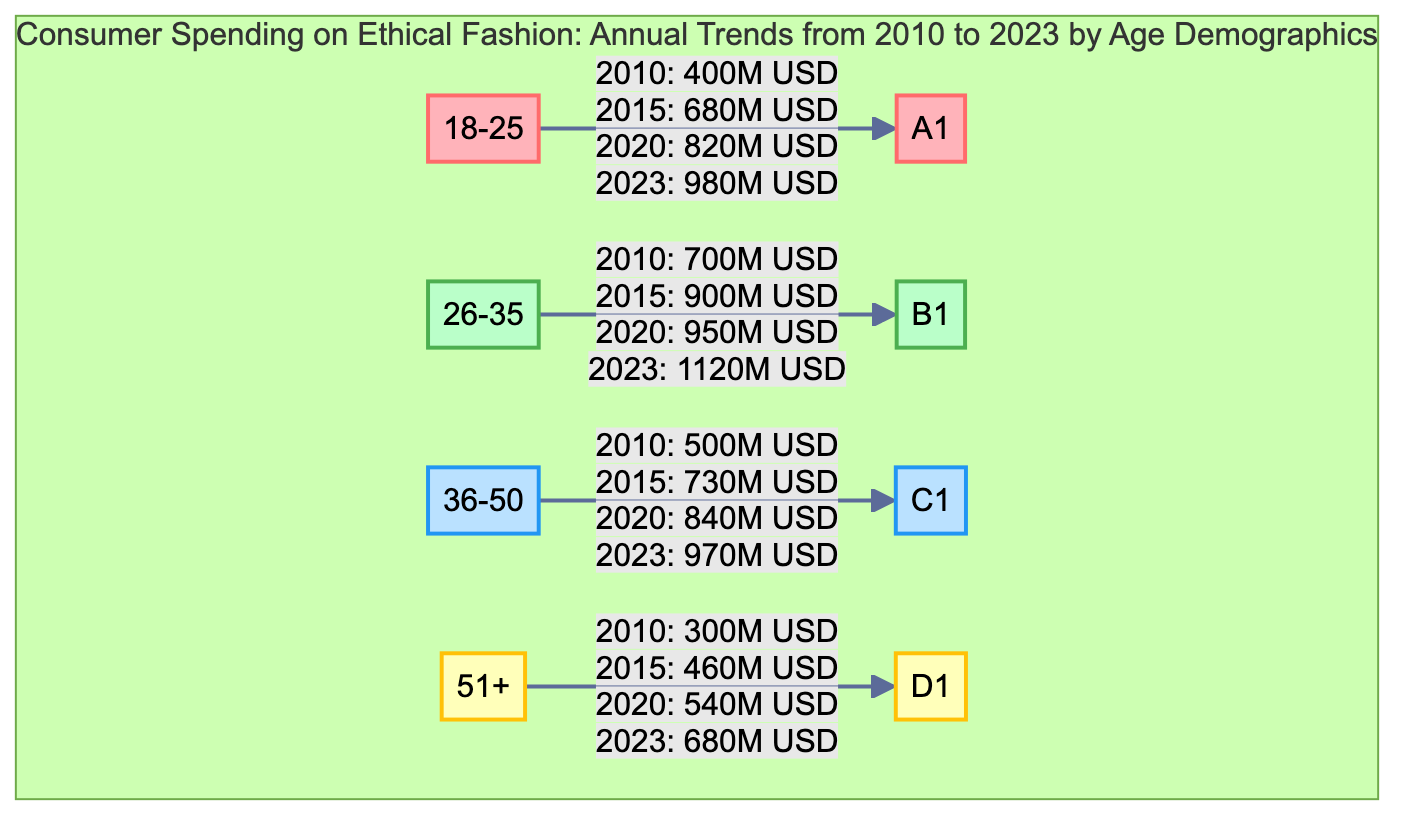What is the spending for the 18-25 age group in 2023? The diagram indicates that the spending for the 18-25 age group in 2023 is displayed directly next to the node labeled "18-25". According to the provided information, this amount is 980 million USD.
Answer: 980M USD Which age group had the highest spending in 2015? To find the highest spending in 2015, we can compare the values provided next to each age group. The spending for each age group in 2015 is: 18-25: 680M, 26-35: 900M, 36-50: 730M, and 51+: 460M. 26-35 has the highest amount at 900 million USD.
Answer: 26-35 What was the increase in spending for the 36-50 age group from 2010 to 2020? The initial spending for the 36-50 age group in 2010 was 500 million USD and in 2020 it was 840 million USD. To find the increase, subtract the 2010 value from the 2020 value: 840M - 500M = 340M.
Answer: 340M USD How many age groups are displayed in the diagram? The diagram showcases spending information for a total of four distinct age groups: 18-25, 26-35, 36-50, and 51+. Thus, the total number of nodes representing age groups is four.
Answer: 4 What is the spending trend for the 51+ age group from 2010 to 2023? By examining the data provided, the spending for the 51+ age group is recorded as follows: 2010: 300M, 2015: 460M, 2020: 540M, and 2023: 680M. This shows a consistent upward trend in spending over these years.
Answer: Upward trend Which age group saw the smallest increase between 2020 and 2023? To determine which age group had the smallest increase between 2020 and 2023, we need to look at the changes in spending: 18-25: 980M - 820M = 160M; 26-35: 1120M - 950M = 170M; 36-50: 970M - 840M = 130M; 51+: 680M - 540M = 140M. The smallest increase was for the 36-50 age group at 130 million USD.
Answer: 36-50 What was the spending for the 26-35 age group in 2020? The diagram presents the 2020 spending for the 26-35 age group as listed next to its corresponding node. The amount is 950 million USD.
Answer: 950M USD Which age group had the least spending in 2010? In 2010, the spending amounts for each age group were as follows: 18-25: 400M, 26-35: 700M, 36-50: 500M, and 51+: 300M. The 51+ age group had the least spending at 300 million USD.
Answer: 51+ 